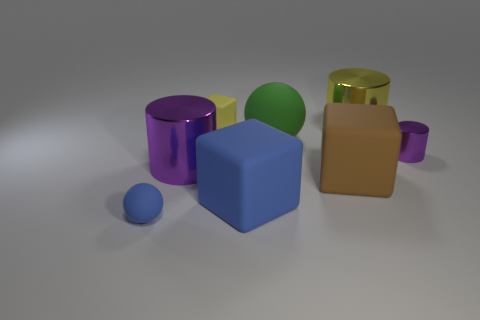The purple cylinder left of the cylinder that is behind the small purple cylinder is made of what material?
Your response must be concise. Metal. Is the number of balls that are on the left side of the green rubber sphere greater than the number of large gray shiny spheres?
Your answer should be compact. Yes. Are there any tiny blue things made of the same material as the large blue object?
Give a very brief answer. Yes. Do the shiny thing in front of the small purple cylinder and the small purple metallic object have the same shape?
Your response must be concise. Yes. There is a tiny object that is behind the metallic object to the right of the yellow metallic cylinder; how many big green rubber balls are in front of it?
Your response must be concise. 1. Is the number of tiny yellow matte objects that are in front of the small metal cylinder less than the number of small blue matte things that are in front of the large green rubber ball?
Keep it short and to the point. Yes. What color is the other tiny thing that is the same shape as the brown object?
Provide a succinct answer. Yellow. The yellow cylinder is what size?
Provide a short and direct response. Large. How many yellow shiny cylinders are the same size as the brown matte thing?
Keep it short and to the point. 1. Do the tiny thing that is on the right side of the blue block and the ball that is behind the brown matte cube have the same material?
Your answer should be very brief. No. 